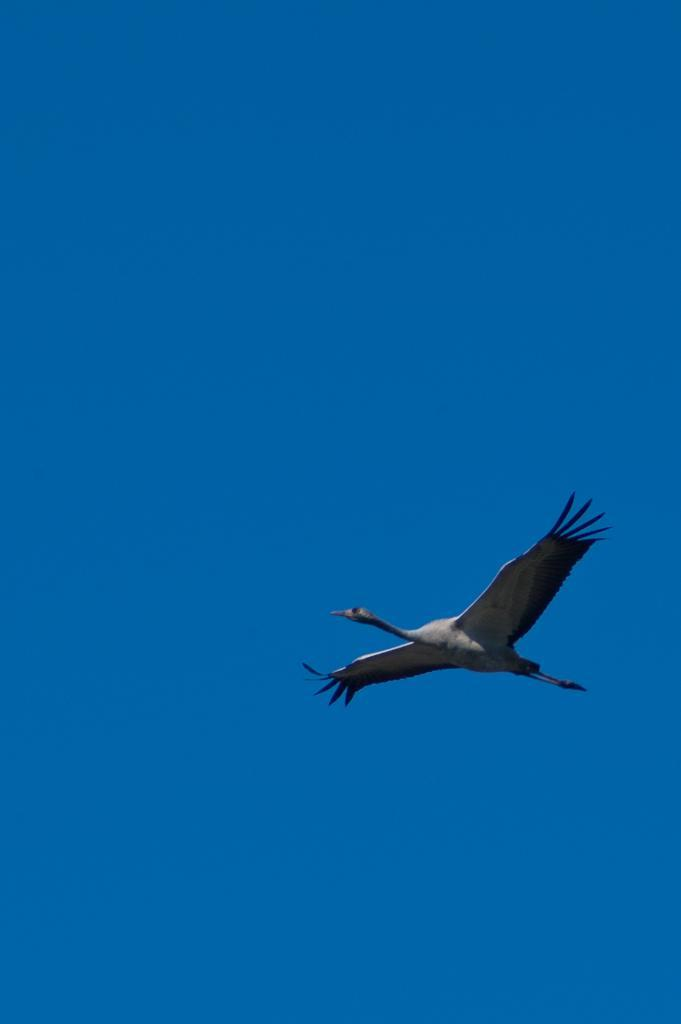What type of animal can be seen in the image? There is a bird in the image. What is visible in the background of the image? There is a sky visible in the background of the image. How many cakes are being held by the bird's neck in the image? There are no cakes present in the image, and the bird does not have a neck. 